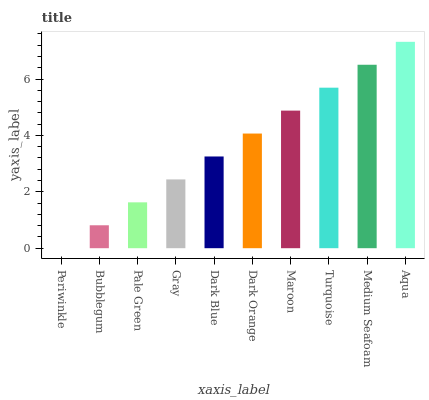Is Periwinkle the minimum?
Answer yes or no. Yes. Is Aqua the maximum?
Answer yes or no. Yes. Is Bubblegum the minimum?
Answer yes or no. No. Is Bubblegum the maximum?
Answer yes or no. No. Is Bubblegum greater than Periwinkle?
Answer yes or no. Yes. Is Periwinkle less than Bubblegum?
Answer yes or no. Yes. Is Periwinkle greater than Bubblegum?
Answer yes or no. No. Is Bubblegum less than Periwinkle?
Answer yes or no. No. Is Dark Orange the high median?
Answer yes or no. Yes. Is Dark Blue the low median?
Answer yes or no. Yes. Is Aqua the high median?
Answer yes or no. No. Is Periwinkle the low median?
Answer yes or no. No. 